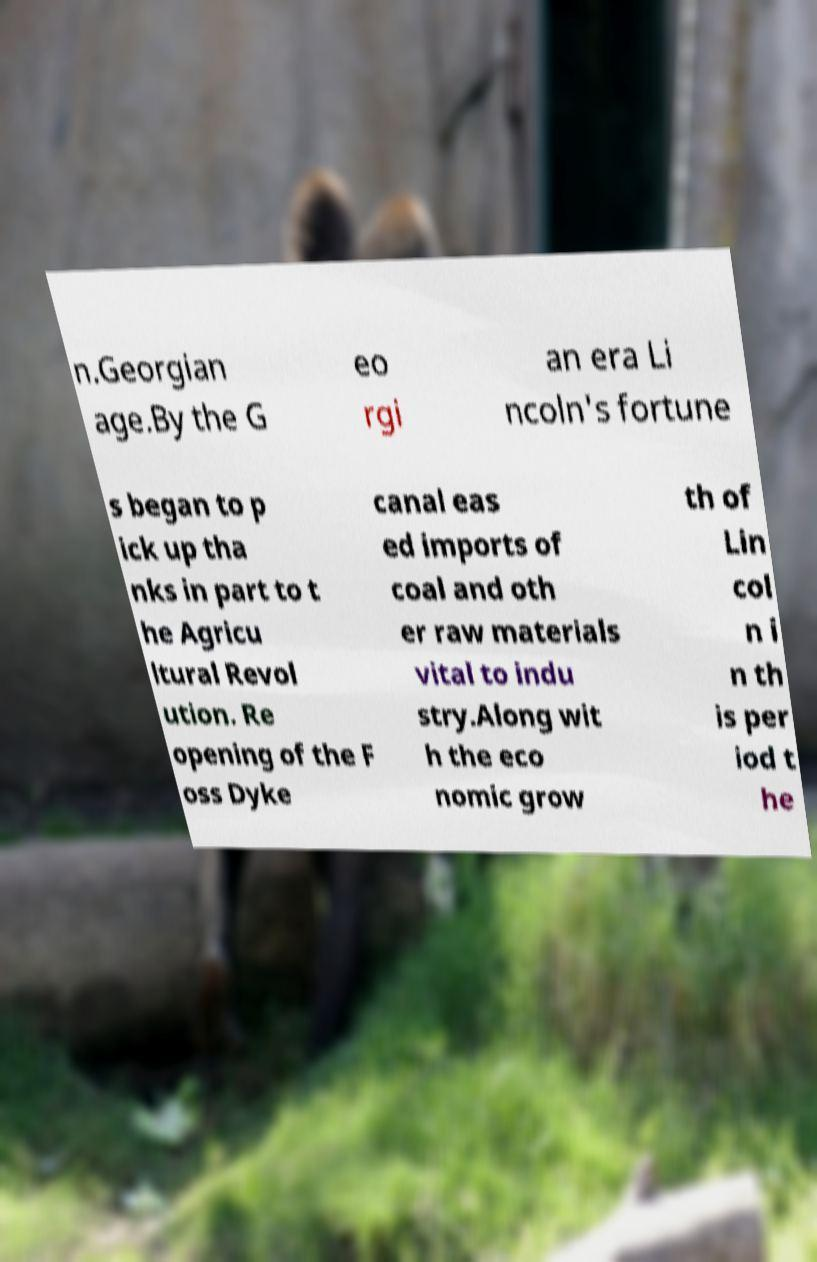Please identify and transcribe the text found in this image. n.Georgian age.By the G eo rgi an era Li ncoln's fortune s began to p ick up tha nks in part to t he Agricu ltural Revol ution. Re opening of the F oss Dyke canal eas ed imports of coal and oth er raw materials vital to indu stry.Along wit h the eco nomic grow th of Lin col n i n th is per iod t he 